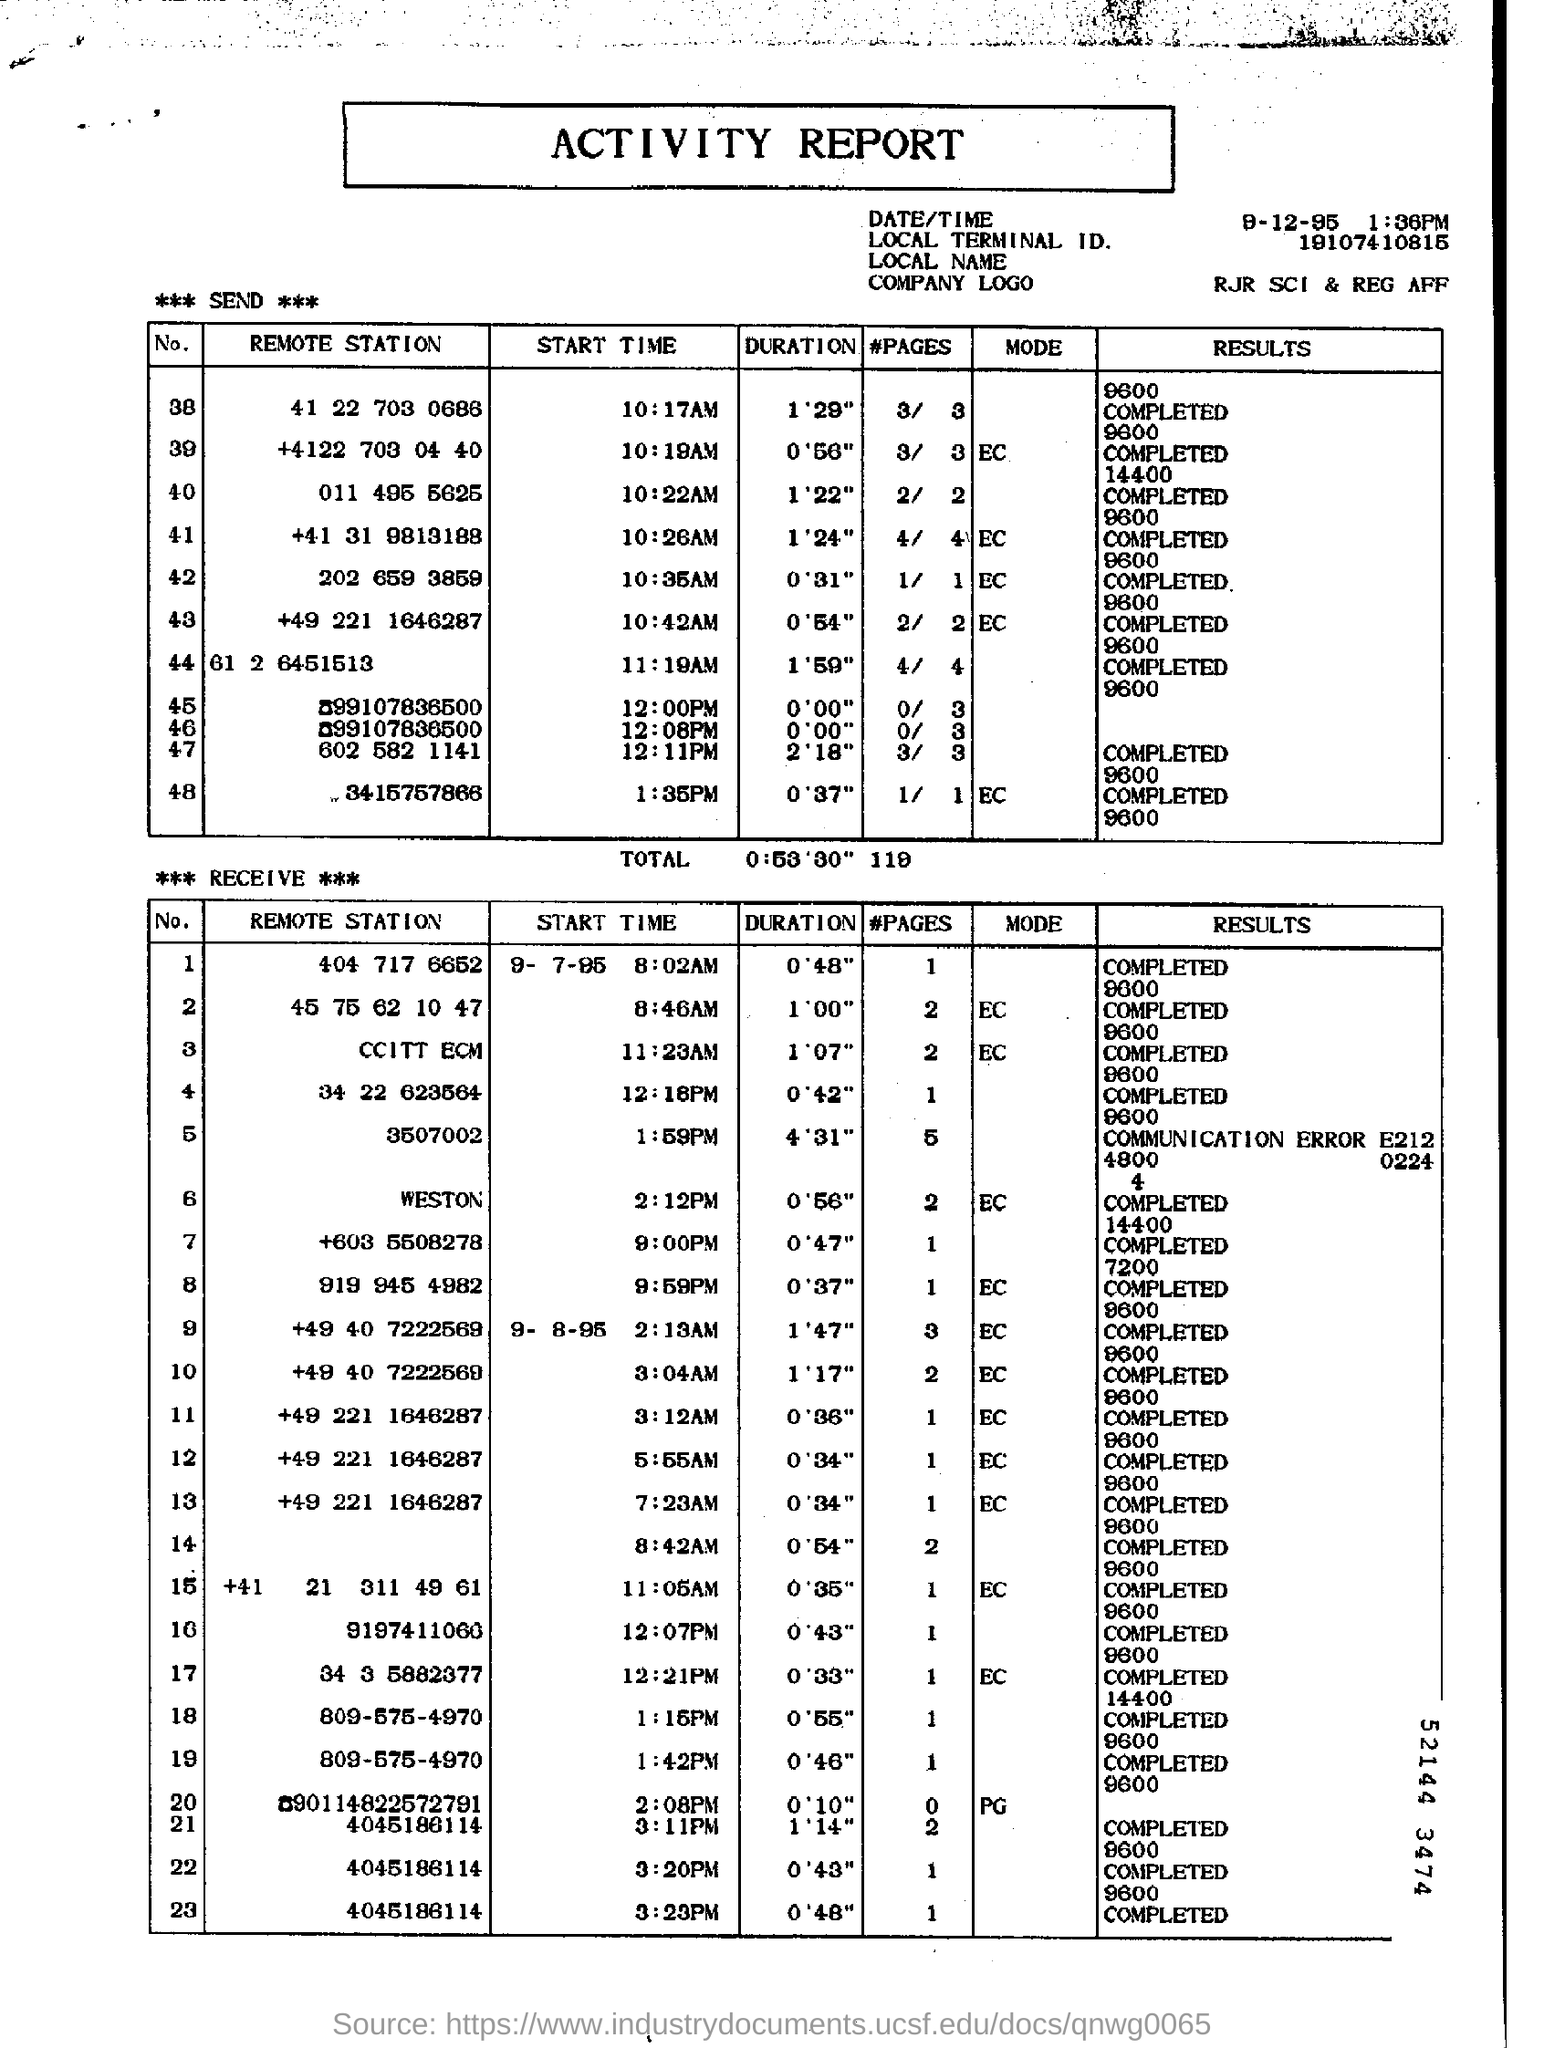What is the "Duration" for "Remote Station" "202 659 3859"?
Keep it short and to the point. 0'31". What is the "Result" for "Remote Station" "011 4955625"?
Your answer should be very brief. 14400 COMPLETED. What is the "START TIME" for "Remote Station" "011 4955625"?
Your answer should be compact. 10:22AM. What is the "START TIME" for "Remote Station" "202 659 3859"?
Keep it short and to the point. 10:35AM. What is the "START TIME" for "Remote Station" "3507002"?
Provide a short and direct response. 1:59PM. What is the "START TIME" for "Remote Station" "919 945 4982"?
Make the answer very short. 9:59PM. What is the Local Terminal ID?
Your answer should be very brief. 19107410815. What is the "Duration" for "Remote Station" "+603 5508278"?
Offer a terse response. 0'47". What is the "Start Time" for "Remote Station" "+603 5508278"?
Your response must be concise. 9:00PM. 